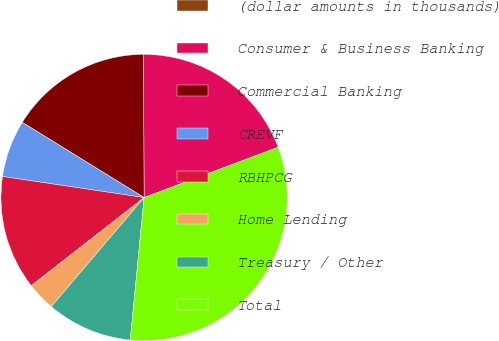Convert chart to OTSL. <chart><loc_0><loc_0><loc_500><loc_500><pie_chart><fcel>(dollar amounts in thousands)<fcel>Consumer & Business Banking<fcel>Commercial Banking<fcel>CREVF<fcel>RBHPCG<fcel>Home Lending<fcel>Treasury / Other<fcel>Total<nl><fcel>0.0%<fcel>19.35%<fcel>16.13%<fcel>6.45%<fcel>12.9%<fcel>3.23%<fcel>9.68%<fcel>32.26%<nl></chart> 